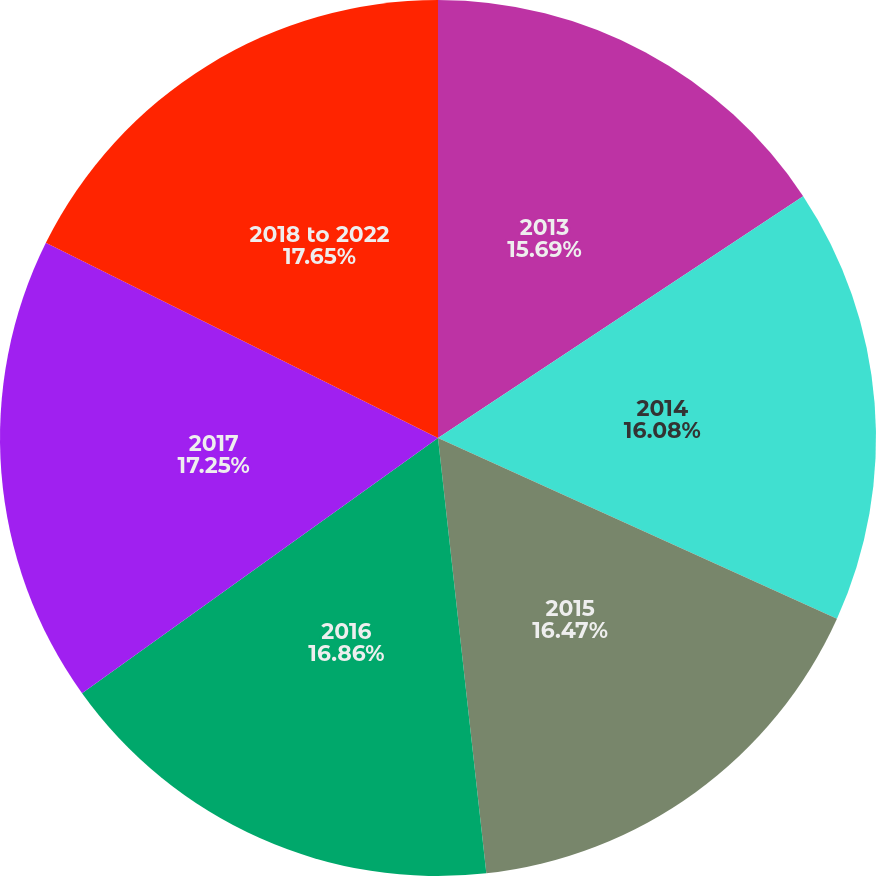<chart> <loc_0><loc_0><loc_500><loc_500><pie_chart><fcel>2013<fcel>2014<fcel>2015<fcel>2016<fcel>2017<fcel>2018 to 2022<nl><fcel>15.69%<fcel>16.08%<fcel>16.47%<fcel>16.86%<fcel>17.25%<fcel>17.65%<nl></chart> 